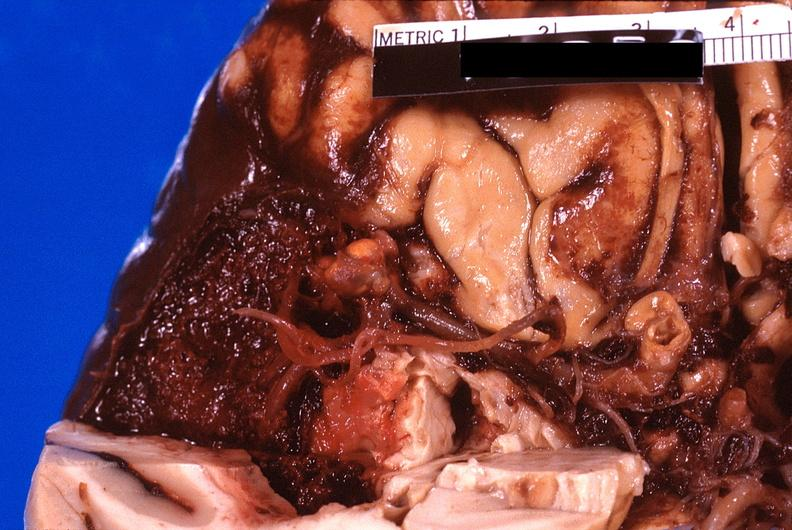why does this image show brain, subarachanoid hemorrhage?
Answer the question using a single word or phrase. Due to ruptured aneurysm 